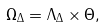Convert formula to latex. <formula><loc_0><loc_0><loc_500><loc_500>\Omega _ { \Delta } = \Lambda _ { \Delta } \times \Theta ,</formula> 